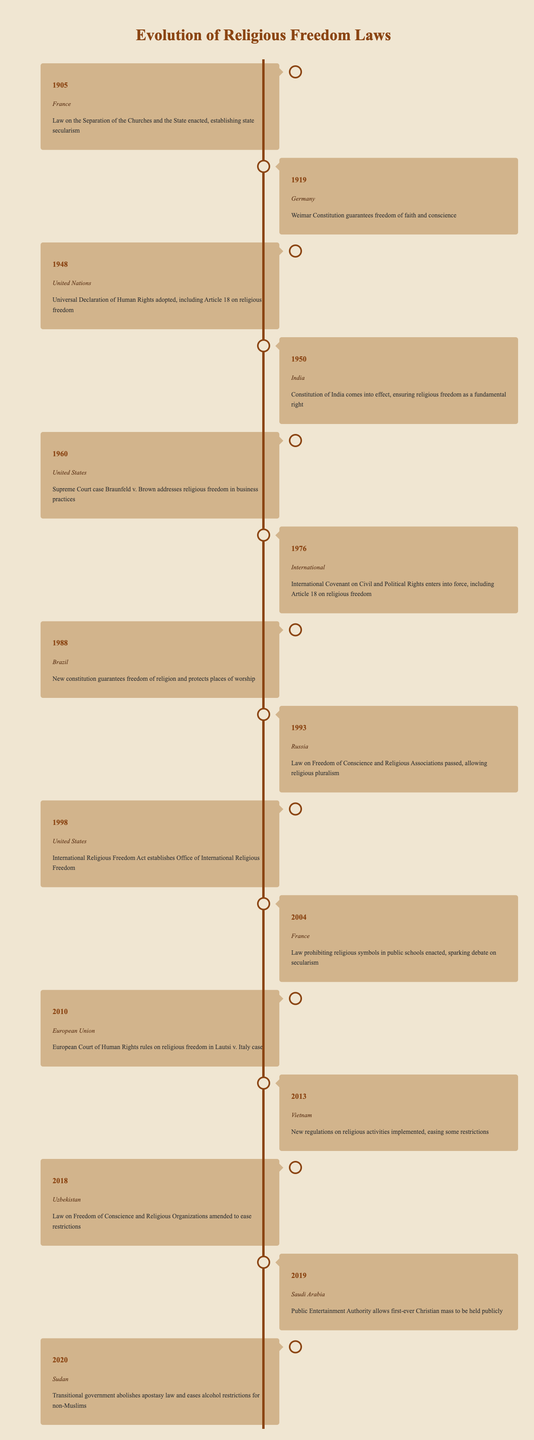What year did the Weimar Constitution guarantee freedom of faith and conscience in Germany? According to the timeline, the Weimar Constitution in Germany was enacted in 1919.
Answer: 1919 Which country enacted a law on the separation of churches and the state in 1905? The timeline states that France enacted this law in 1905, establishing state secularism.
Answer: France How many events related to religious freedom occurred in the United States according to the timeline? The timeline mentions two events in the United States: one in 1960 regarding a Supreme Court case and another in 1998 establishing the Office of International Religious Freedom.
Answer: 2 Did Brazil's new constitution in 1988 guarantee freedom of religion? Yes, the timeline clearly states that Brazil's new constitution guaranteed freedom of religion and offered protection for places of worship.
Answer: Yes In which year was the International Covenant on Civil and Political Rights entered into force? The timeline specifies that the International Covenant on Civil and Political Rights entered into force in 1976, which included Article 18 on religious freedom.
Answer: 1976 What is the total number of countries or regions mentioned in the timeline for the year 2020 or later? The years listed are 2018 (Uzbekistan), 2019 (Saudi Arabia), and 2020 (Sudan), which accounts for three distinct countries or regions mentioned after 2018.
Answer: 3 Which country eased restrictions on religious activities in 2013? According to the timeline, Vietnam implemented new regulations in 2013 that eased some restrictions on religious activities.
Answer: Vietnam What significant event related to religious freedom occurred in Saudi Arabia in 2019? The timeline indicates that in 2019, the Public Entertainment Authority in Saudi Arabia allowed the first-ever Christian mass to be held publicly.
Answer: First-ever public Christian mass Was there a shift towards more religious freedom in Uzbekistan in 2018? Yes, the timeline mentions that the law on Freedom of Conscience and Religious Organizations was amended in Uzbekistan to ease restrictions, indicating a shift toward more religious freedom.
Answer: Yes What was the significance of the United Nations adopting the Universal Declaration of Human Rights in 1948 concerning religious freedom? The timeline states that this declaration included Article 18, which specifically addresses religious freedom, making it a critical international standard.
Answer: Establishes religious freedom as a right 